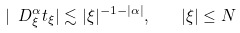<formula> <loc_0><loc_0><loc_500><loc_500>| \ D _ { \xi } ^ { \alpha } t _ { \xi } | \lesssim | \xi | ^ { - 1 - | \alpha | } , \quad | \xi | \leq N</formula> 